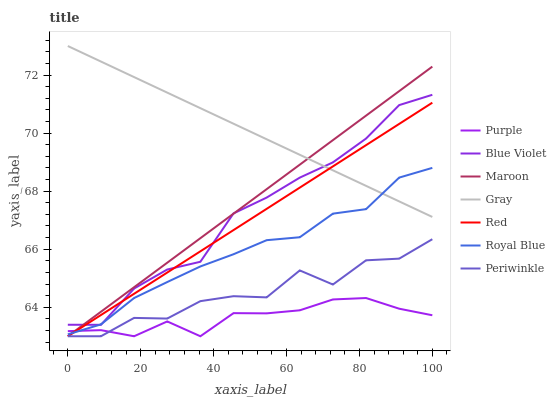Does Maroon have the minimum area under the curve?
Answer yes or no. No. Does Maroon have the maximum area under the curve?
Answer yes or no. No. Is Purple the smoothest?
Answer yes or no. No. Is Purple the roughest?
Answer yes or no. No. Does Royal Blue have the lowest value?
Answer yes or no. No. Does Maroon have the highest value?
Answer yes or no. No. Is Purple less than Blue Violet?
Answer yes or no. Yes. Is Gray greater than Periwinkle?
Answer yes or no. Yes. Does Purple intersect Blue Violet?
Answer yes or no. No. 